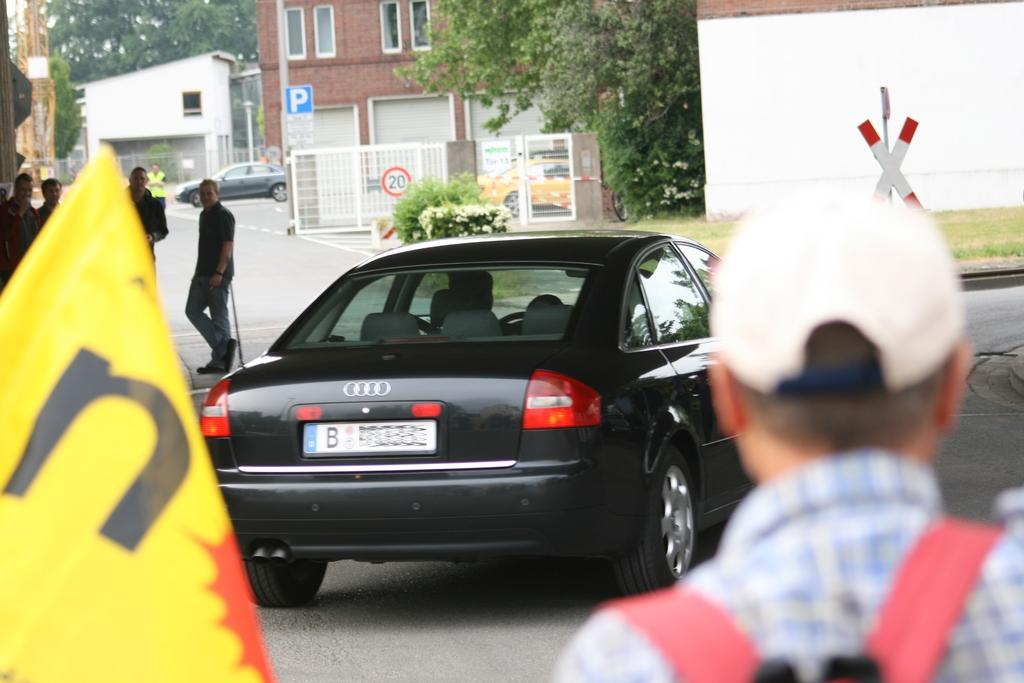<image>
Present a compact description of the photo's key features. A black Audi with a license plate that starts with B is parked in a shady area. 